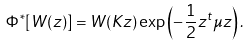Convert formula to latex. <formula><loc_0><loc_0><loc_500><loc_500>\Phi ^ { \ast } [ W ( z ) ] = W ( K z ) \exp \left ( - \frac { 1 } { 2 } z ^ { t } \mu z \right ) .</formula> 